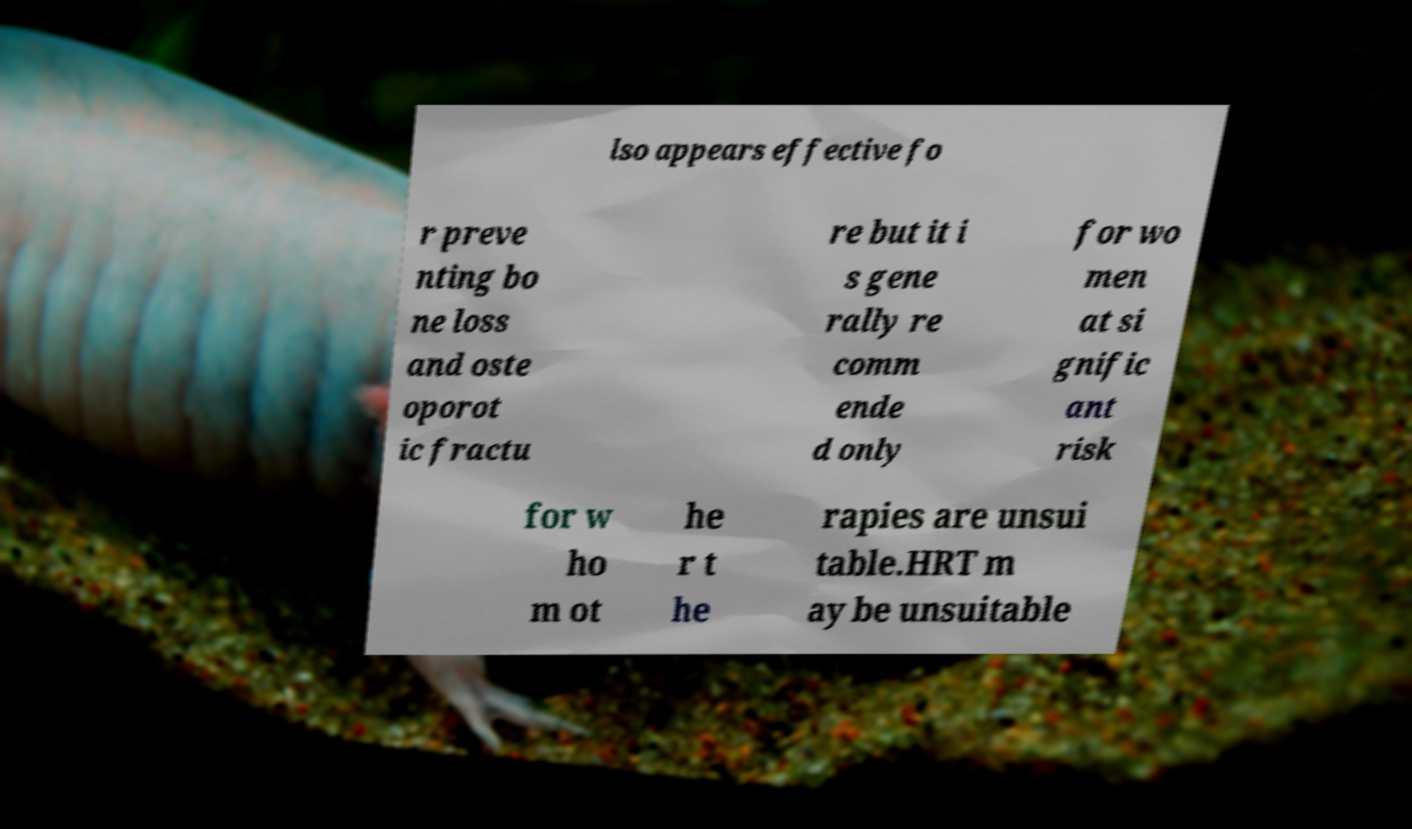Could you extract and type out the text from this image? lso appears effective fo r preve nting bo ne loss and oste oporot ic fractu re but it i s gene rally re comm ende d only for wo men at si gnific ant risk for w ho m ot he r t he rapies are unsui table.HRT m ay be unsuitable 